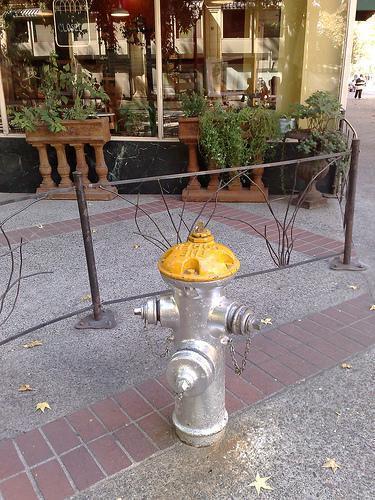How many fire hydrants are shown?
Give a very brief answer. 1. How many planters are there?
Give a very brief answer. 3. 